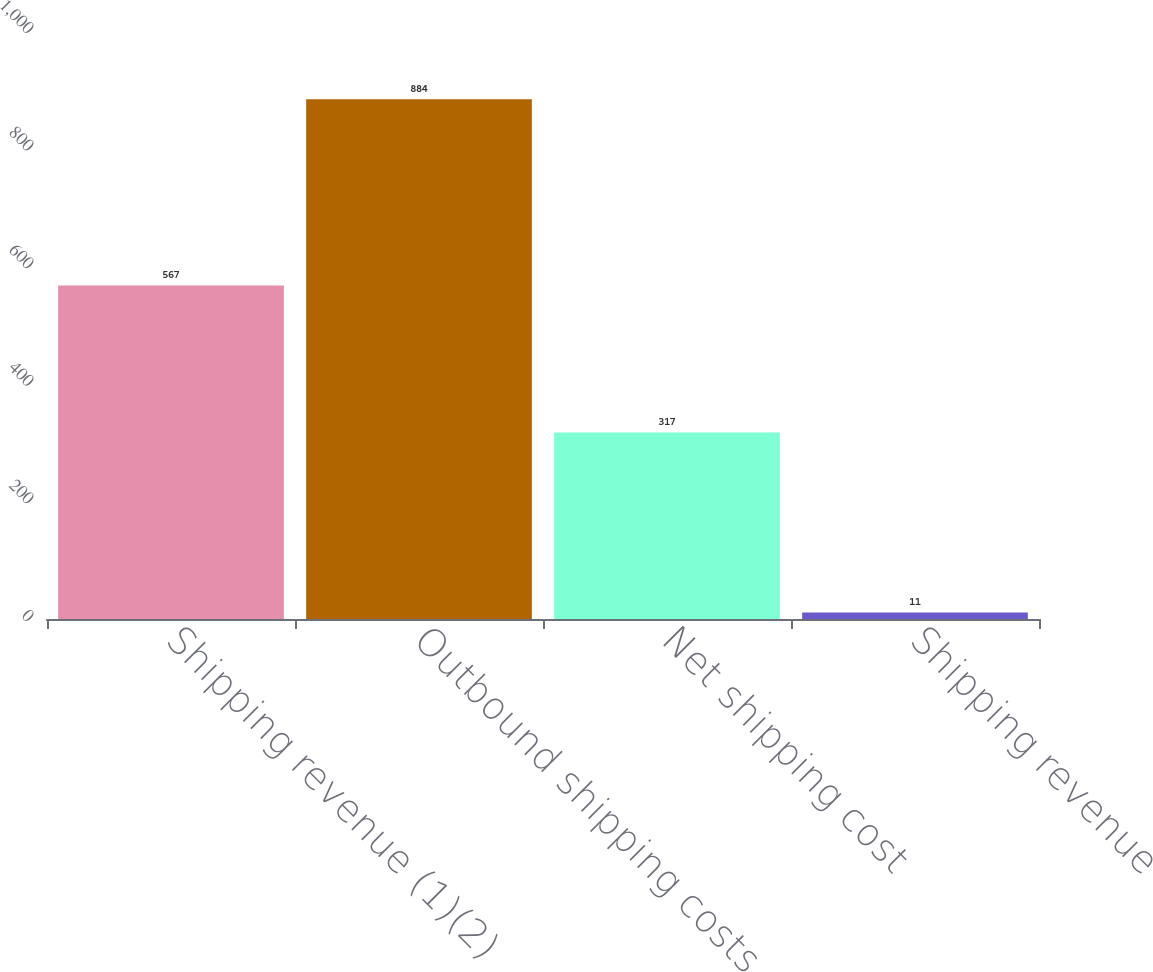Convert chart to OTSL. <chart><loc_0><loc_0><loc_500><loc_500><bar_chart><fcel>Shipping revenue (1)(2)<fcel>Outbound shipping costs<fcel>Net shipping cost<fcel>Shipping revenue<nl><fcel>567<fcel>884<fcel>317<fcel>11<nl></chart> 